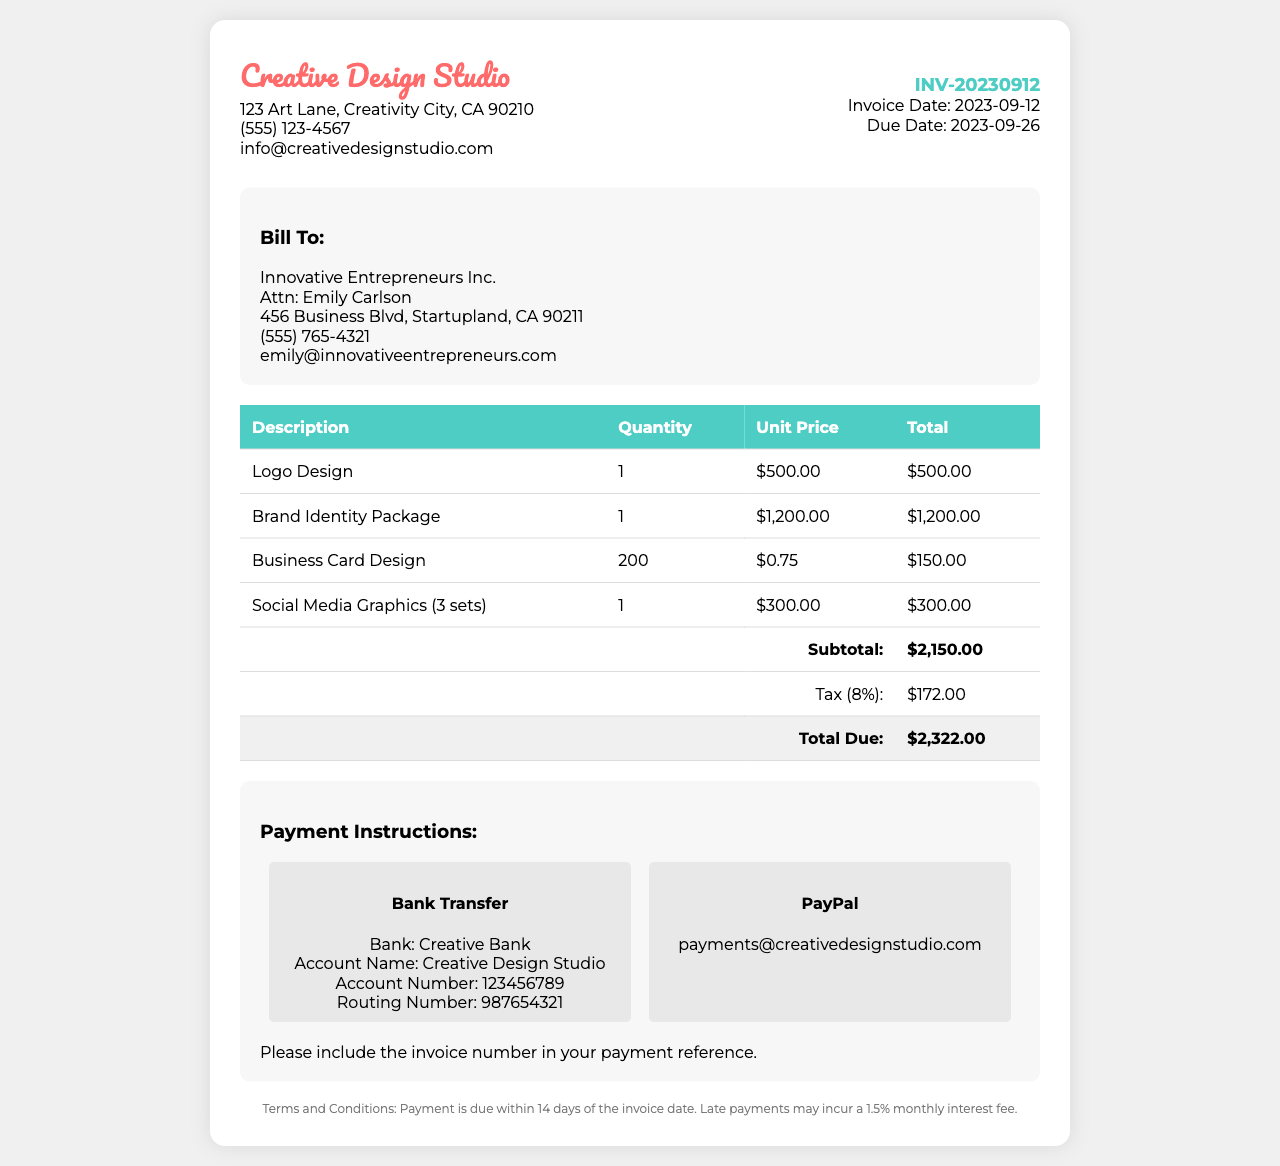What is the invoice number? The invoice number is a unique identifier for this document, stated clearly in the invoice details section.
Answer: INV-20230912 Who is the client? The client information includes the name and details of the company receiving the invoice.
Answer: Innovative Entrepreneurs Inc What is the total due amount? The total due is the final amount that needs to be paid, calculated after tax has been added to the subtotal.
Answer: $2,322.00 When is the payment due date? The payment due date indicates the deadline for payment, as mentioned in the invoice details.
Answer: 2023-09-26 What is the tax percentage applied? The tax percentage shows the rate at which tax is calculated on the subtotal, as noted in the document.
Answer: 8% How many business cards were designed? This number reflects the quantity of business cards included in the services rendered, as detailed in the itemized list.
Answer: 200 What payment methods are offered? This describes the different ways in which the client can pay, mentioned under the payment instructions.
Answer: Bank Transfer, PayPal What is the subtotal before tax? The subtotal represents the sum of all item costs before tax is added, listed in the total calculations.
Answer: $2,150.00 What is the name of the design studio? This identifies the business that has issued the invoice, prominently displayed at the top of the document.
Answer: Creative Design Studio 